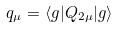<formula> <loc_0><loc_0><loc_500><loc_500>q _ { \mu } = \langle g | Q _ { 2 \mu } | g \rangle</formula> 